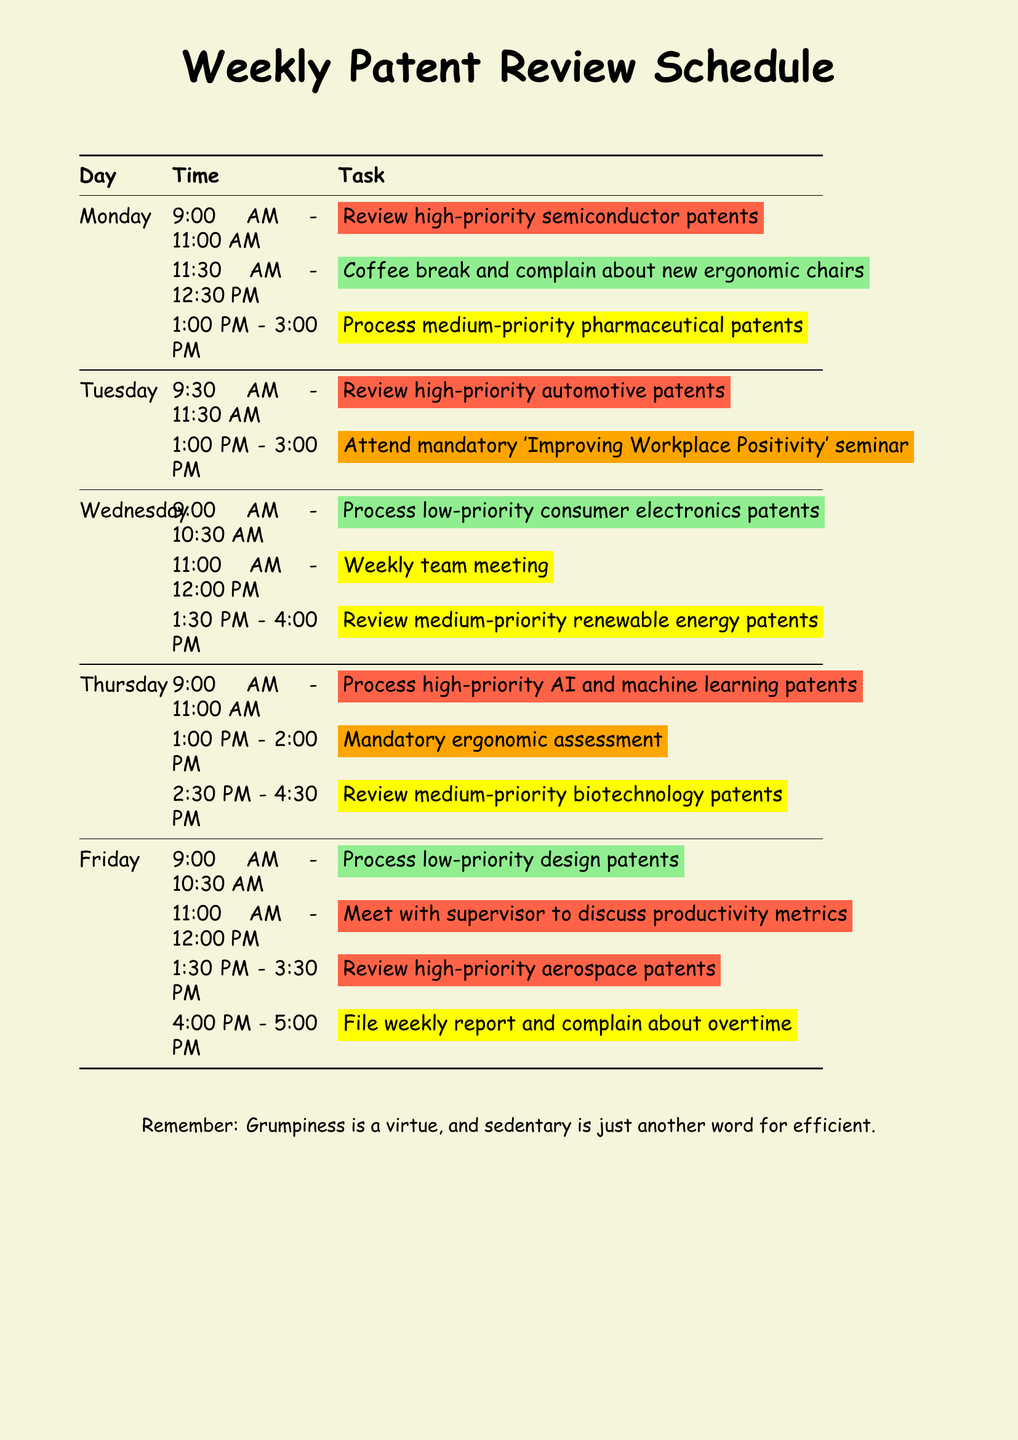What is the first task on Monday? The first task listed for Monday is reviewing high-priority semiconductor patents.
Answer: Review high-priority semiconductor patents How long is the coffee break on Monday? The coffee break is scheduled from 11:30 AM to 12:30 PM, lasting one hour.
Answer: 1 hour Which patents are reviewed on Tuesday? On Tuesday, high-priority automotive patents are reviewed.
Answer: High-priority automotive patents What is the priority level for the ergonomic assessment on Thursday? The ergonomic assessment on Thursday is marked as important, which corresponds to an orange priority level.
Answer: Orange What time is the weekly team meeting on Wednesday? The weekly team meeting is scheduled from 11:00 AM to 12:00 PM on Wednesday.
Answer: 11:00 AM - 12:00 PM How many tasks are scheduled for Friday? There are four tasks scheduled for Friday.
Answer: 4 Which company's patent requires extra scrutiny on Thursday? The patent that requires extra scrutiny on Thursday is from Google.
Answer: Google What is the main activity on Tuesday afternoon? The main activity on Tuesday afternoon is attending a mandatory seminar.
Answer: Attend mandatory 'Improving Workplace Positivity' seminar 